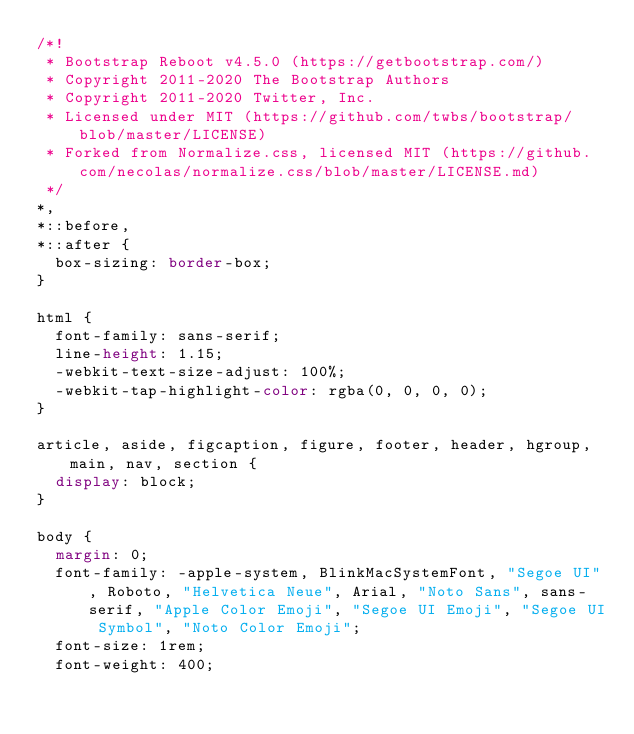Convert code to text. <code><loc_0><loc_0><loc_500><loc_500><_CSS_>/*!
 * Bootstrap Reboot v4.5.0 (https://getbootstrap.com/)
 * Copyright 2011-2020 The Bootstrap Authors
 * Copyright 2011-2020 Twitter, Inc.
 * Licensed under MIT (https://github.com/twbs/bootstrap/blob/master/LICENSE)
 * Forked from Normalize.css, licensed MIT (https://github.com/necolas/normalize.css/blob/master/LICENSE.md)
 */
*,
*::before,
*::after {
  box-sizing: border-box;
}

html {
  font-family: sans-serif;
  line-height: 1.15;
  -webkit-text-size-adjust: 100%;
  -webkit-tap-highlight-color: rgba(0, 0, 0, 0);
}

article, aside, figcaption, figure, footer, header, hgroup, main, nav, section {
  display: block;
}

body {
  margin: 0;
  font-family: -apple-system, BlinkMacSystemFont, "Segoe UI", Roboto, "Helvetica Neue", Arial, "Noto Sans", sans-serif, "Apple Color Emoji", "Segoe UI Emoji", "Segoe UI Symbol", "Noto Color Emoji";
  font-size: 1rem;
  font-weight: 400;</code> 